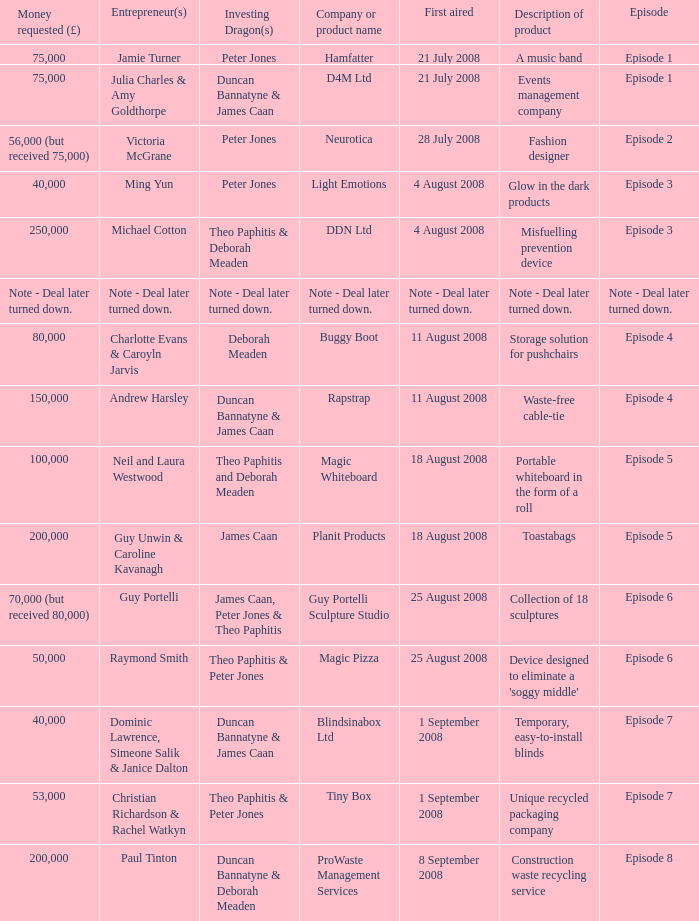Can you parse all the data within this table? {'header': ['Money requested (£)', 'Entrepreneur(s)', 'Investing Dragon(s)', 'Company or product name', 'First aired', 'Description of product', 'Episode'], 'rows': [['75,000', 'Jamie Turner', 'Peter Jones', 'Hamfatter', '21 July 2008', 'A music band', 'Episode 1'], ['75,000', 'Julia Charles & Amy Goldthorpe', 'Duncan Bannatyne & James Caan', 'D4M Ltd', '21 July 2008', 'Events management company', 'Episode 1'], ['56,000 (but received 75,000)', 'Victoria McGrane', 'Peter Jones', 'Neurotica', '28 July 2008', 'Fashion designer', 'Episode 2'], ['40,000', 'Ming Yun', 'Peter Jones', 'Light Emotions', '4 August 2008', 'Glow in the dark products', 'Episode 3'], ['250,000', 'Michael Cotton', 'Theo Paphitis & Deborah Meaden', 'DDN Ltd', '4 August 2008', 'Misfuelling prevention device', 'Episode 3'], ['Note - Deal later turned down.', 'Note - Deal later turned down.', 'Note - Deal later turned down.', 'Note - Deal later turned down.', 'Note - Deal later turned down.', 'Note - Deal later turned down.', 'Note - Deal later turned down.'], ['80,000', 'Charlotte Evans & Caroyln Jarvis', 'Deborah Meaden', 'Buggy Boot', '11 August 2008', 'Storage solution for pushchairs', 'Episode 4'], ['150,000', 'Andrew Harsley', 'Duncan Bannatyne & James Caan', 'Rapstrap', '11 August 2008', 'Waste-free cable-tie', 'Episode 4'], ['100,000', 'Neil and Laura Westwood', 'Theo Paphitis and Deborah Meaden', 'Magic Whiteboard', '18 August 2008', 'Portable whiteboard in the form of a roll', 'Episode 5'], ['200,000', 'Guy Unwin & Caroline Kavanagh', 'James Caan', 'Planit Products', '18 August 2008', 'Toastabags', 'Episode 5'], ['70,000 (but received 80,000)', 'Guy Portelli', 'James Caan, Peter Jones & Theo Paphitis', 'Guy Portelli Sculpture Studio', '25 August 2008', 'Collection of 18 sculptures', 'Episode 6'], ['50,000', 'Raymond Smith', 'Theo Paphitis & Peter Jones', 'Magic Pizza', '25 August 2008', "Device designed to eliminate a 'soggy middle'", 'Episode 6'], ['40,000', 'Dominic Lawrence, Simeone Salik & Janice Dalton', 'Duncan Bannatyne & James Caan', 'Blindsinabox Ltd', '1 September 2008', 'Temporary, easy-to-install blinds', 'Episode 7'], ['53,000', 'Christian Richardson & Rachel Watkyn', 'Theo Paphitis & Peter Jones', 'Tiny Box', '1 September 2008', 'Unique recycled packaging company', 'Episode 7'], ['200,000', 'Paul Tinton', 'Duncan Bannatyne & Deborah Meaden', 'ProWaste Management Services', '8 September 2008', 'Construction waste recycling service', 'Episode 8']]} When did episode 6 first air with entrepreneur Guy Portelli? 25 August 2008. 